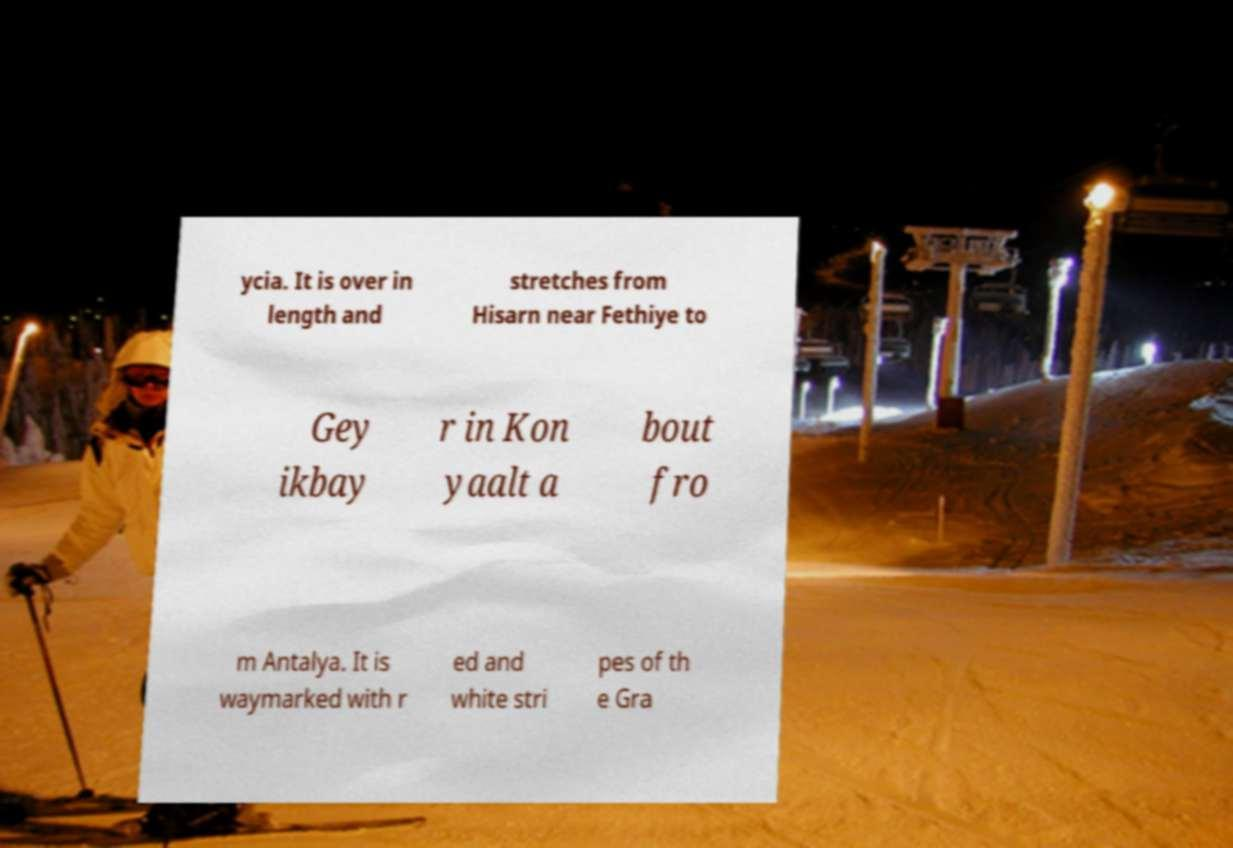There's text embedded in this image that I need extracted. Can you transcribe it verbatim? ycia. It is over in length and stretches from Hisarn near Fethiye to Gey ikbay r in Kon yaalt a bout fro m Antalya. It is waymarked with r ed and white stri pes of th e Gra 